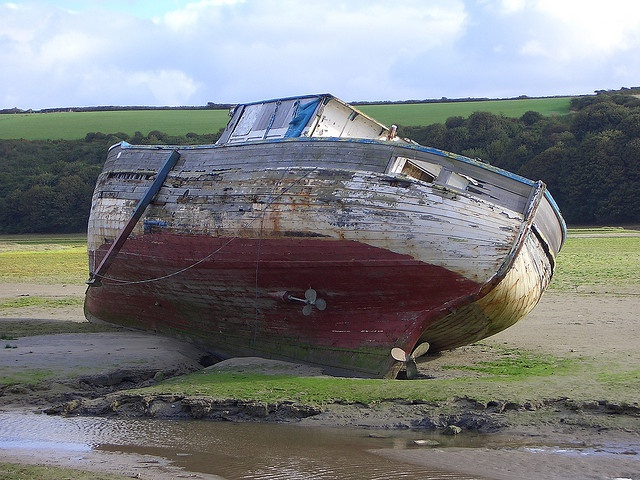Describe the objects in this image and their specific colors. I can see a boat in lightblue, black, gray, and darkgray tones in this image. 